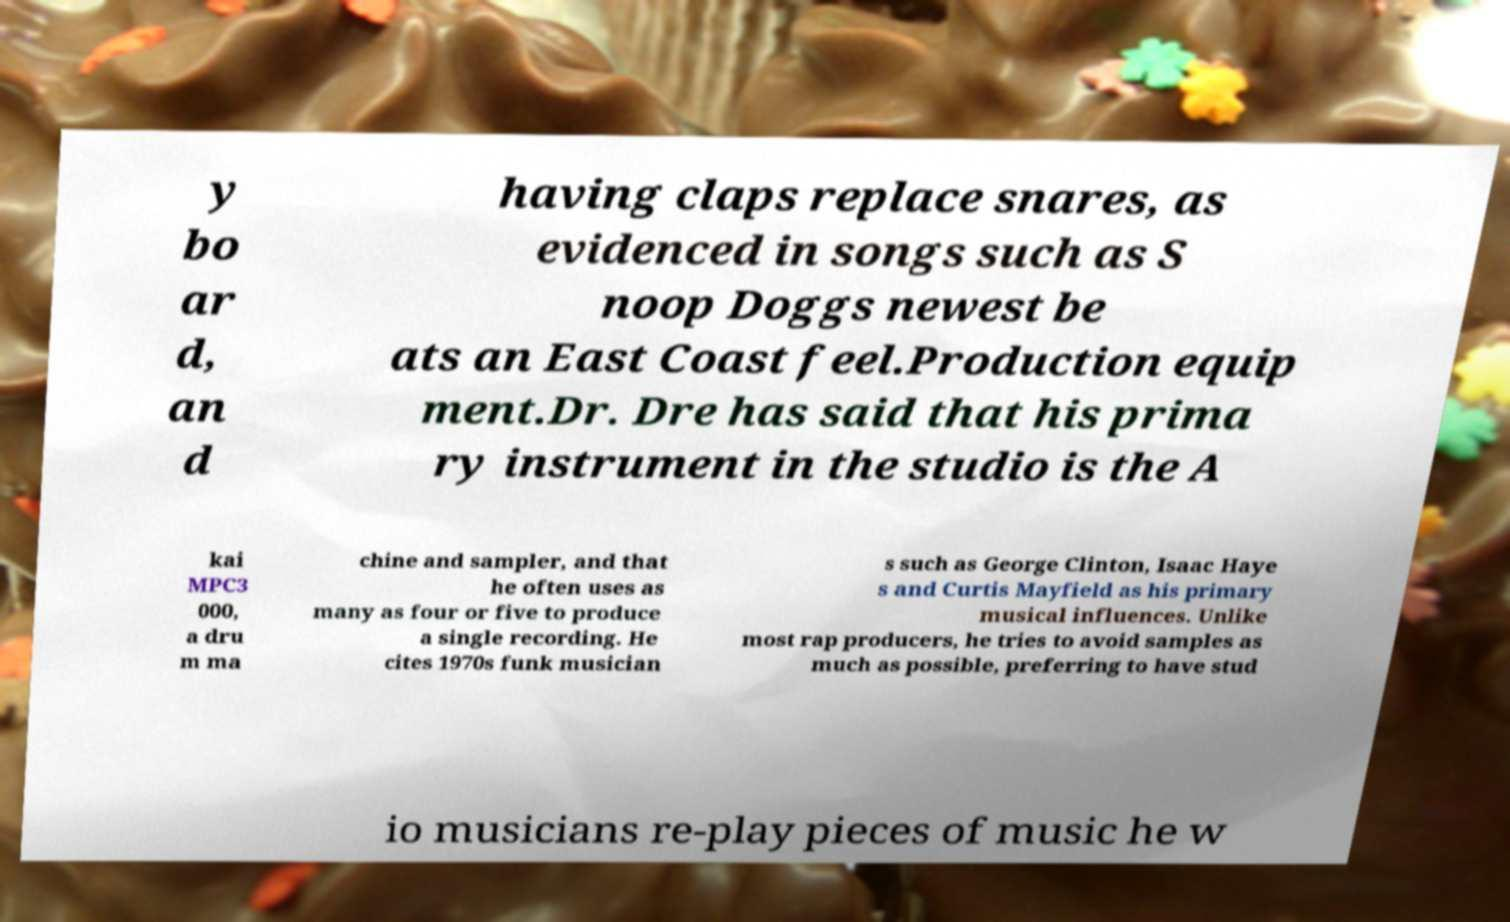Could you assist in decoding the text presented in this image and type it out clearly? y bo ar d, an d having claps replace snares, as evidenced in songs such as S noop Doggs newest be ats an East Coast feel.Production equip ment.Dr. Dre has said that his prima ry instrument in the studio is the A kai MPC3 000, a dru m ma chine and sampler, and that he often uses as many as four or five to produce a single recording. He cites 1970s funk musician s such as George Clinton, Isaac Haye s and Curtis Mayfield as his primary musical influences. Unlike most rap producers, he tries to avoid samples as much as possible, preferring to have stud io musicians re-play pieces of music he w 